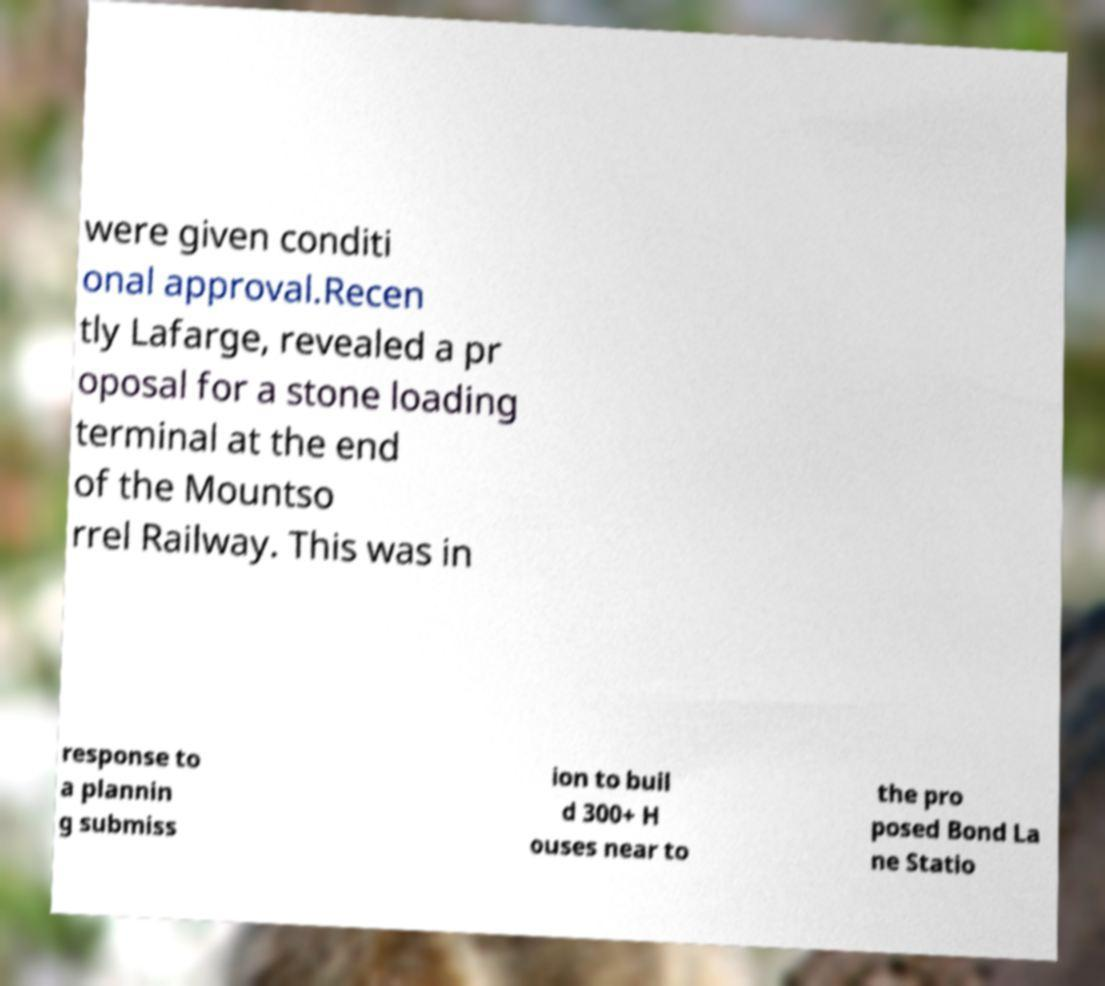Could you extract and type out the text from this image? were given conditi onal approval.Recen tly Lafarge, revealed a pr oposal for a stone loading terminal at the end of the Mountso rrel Railway. This was in response to a plannin g submiss ion to buil d 300+ H ouses near to the pro posed Bond La ne Statio 